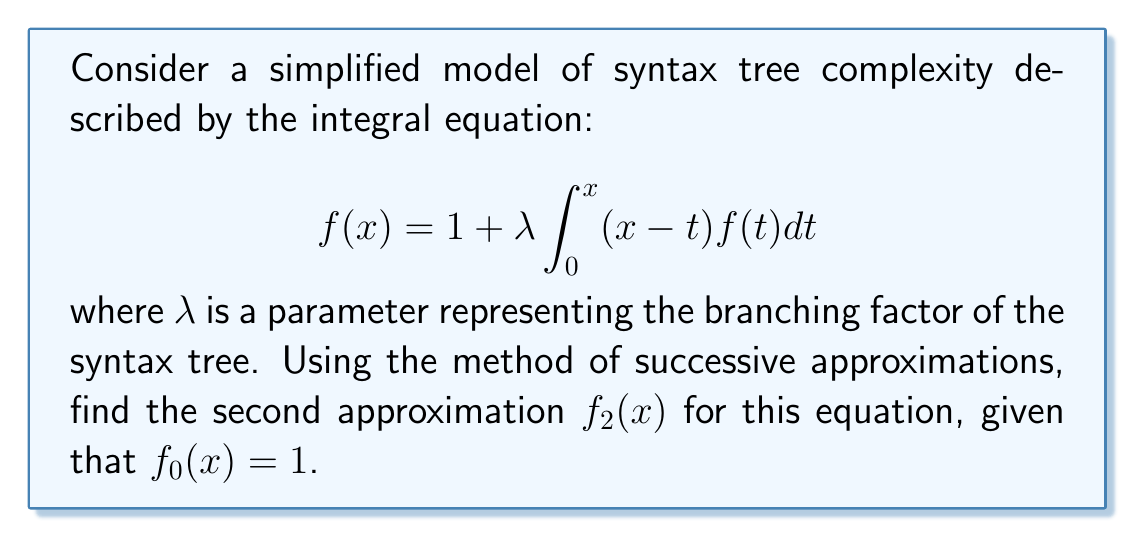Can you solve this math problem? To solve this problem using the method of successive approximations, we follow these steps:

1) We start with $f_0(x) = 1$ as given.

2) For the first approximation, we substitute $f_0(x)$ into the right-hand side of the equation:

   $$f_1(x) = 1 + \lambda \int_0^x (x-t)f_0(t)dt = 1 + \lambda \int_0^x (x-t)dt$$

3) Solve the integral:
   
   $$f_1(x) = 1 + \lambda \left[xt - \frac{t^2}{2}\right]_0^x = 1 + \lambda \left(x^2 - \frac{x^2}{2}\right) = 1 + \frac{\lambda x^2}{2}$$

4) For the second approximation, we substitute $f_1(x)$ into the right-hand side:

   $$f_2(x) = 1 + \lambda \int_0^x (x-t)f_1(t)dt = 1 + \lambda \int_0^x (x-t)\left(1 + \frac{\lambda t^2}{2}\right)dt$$

5) Expand the integrand:

   $$f_2(x) = 1 + \lambda \int_0^x \left(x-t+\frac{\lambda x t^2}{2}-\frac{\lambda t^3}{2}\right)dt$$

6) Integrate term by term:

   $$f_2(x) = 1 + \lambda \left[xt - \frac{t^2}{2} + \frac{\lambda x t^3}{6} - \frac{\lambda t^4}{8}\right]_0^x$$

7) Evaluate the integral:

   $$f_2(x) = 1 + \lambda \left(x^2 - \frac{x^2}{2} + \frac{\lambda x^4}{6} - \frac{\lambda x^4}{8}\right)$$

8) Simplify:

   $$f_2(x) = 1 + \frac{\lambda x^2}{2} + \frac{\lambda^2 x^4}{24}$$

This is the second approximation $f_2(x)$ for the given integral equation.
Answer: $f_2(x) = 1 + \frac{\lambda x^2}{2} + \frac{\lambda^2 x^4}{24}$ 